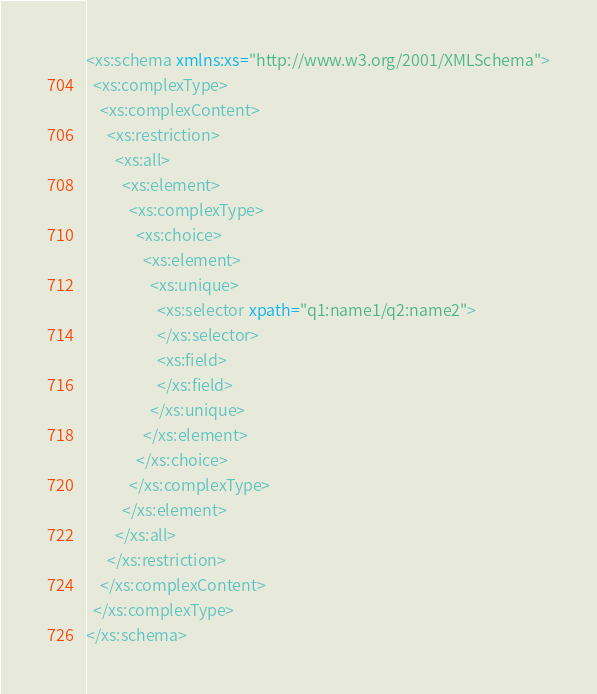Convert code to text. <code><loc_0><loc_0><loc_500><loc_500><_XML_><xs:schema xmlns:xs="http://www.w3.org/2001/XMLSchema">
  <xs:complexType>
    <xs:complexContent>
      <xs:restriction>
        <xs:all>
          <xs:element>
            <xs:complexType>
              <xs:choice>
                <xs:element>
                  <xs:unique>
                    <xs:selector xpath="q1:name1/q2:name2">
                    </xs:selector>
                    <xs:field>
                    </xs:field>
                  </xs:unique>
                </xs:element>
              </xs:choice>
            </xs:complexType>
          </xs:element>
        </xs:all>
      </xs:restriction>
    </xs:complexContent>
  </xs:complexType>
</xs:schema>
</code> 